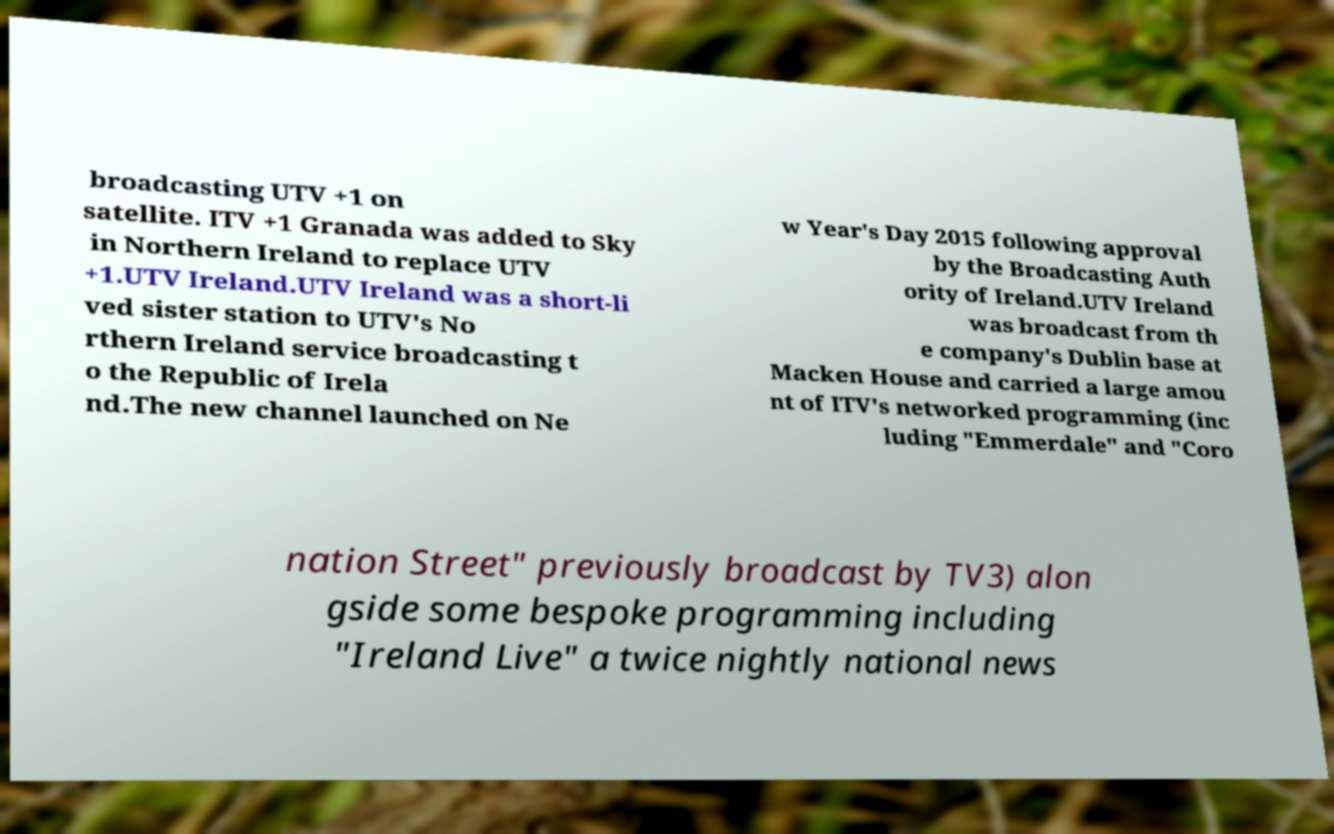Can you accurately transcribe the text from the provided image for me? broadcasting UTV +1 on satellite. ITV +1 Granada was added to Sky in Northern Ireland to replace UTV +1.UTV Ireland.UTV Ireland was a short-li ved sister station to UTV's No rthern Ireland service broadcasting t o the Republic of Irela nd.The new channel launched on Ne w Year's Day 2015 following approval by the Broadcasting Auth ority of Ireland.UTV Ireland was broadcast from th e company's Dublin base at Macken House and carried a large amou nt of ITV's networked programming (inc luding "Emmerdale" and "Coro nation Street" previously broadcast by TV3) alon gside some bespoke programming including "Ireland Live" a twice nightly national news 